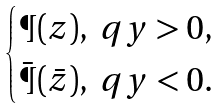<formula> <loc_0><loc_0><loc_500><loc_500>\begin{cases} \P ( z ) , \ q y > 0 , \\ \bar { \P } ( \bar { z } ) , \ q y < 0 . \end{cases}</formula> 